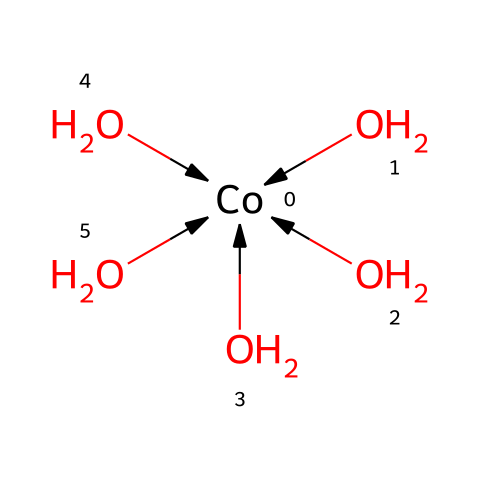What is the central metal ion in this compound? The compound features a cobalt ion, which is shown as the central atom in the formula.
Answer: cobalt How many hydroxide ligands are coordinated to the metal? The chemical structure shows five hydroxide ligands (OH groups) bonded to the cobalt central atom, indicated by the multiple instances of OH and the geometric arrangement.
Answer: five What type of geometric isomerism can this compound exhibit? The compound can exhibit geometric isomerism due to the different arrangements of hydroxide ligands surrounding the cobalt ion, leading to potential cis and trans configurations.
Answer: geometric isomerism How many total oxygen atoms are present in the compound? The compound has five hydroxide ligands, each containing one oxygen atom, leading to a total of five oxygens. The central cobalt is bonded to these, but does not add additional oxygens.
Answer: five What is the coordination number of the central cobalt ion? The coordination number is determined by the number of ligands directly bonded to the central metal. In this structure, the cobalt is surrounded by five hydroxide ligands, thus the coordination number is five.
Answer: five Which type of isomers might be relevant to study in terms of biodiversity? Examining geometric isomers of metal complexes can provide insights into how different arrangements impact biological interactions and availability in the environment, particularly in relation to nutrient uptake in various ecosystems.
Answer: geometric isomers 